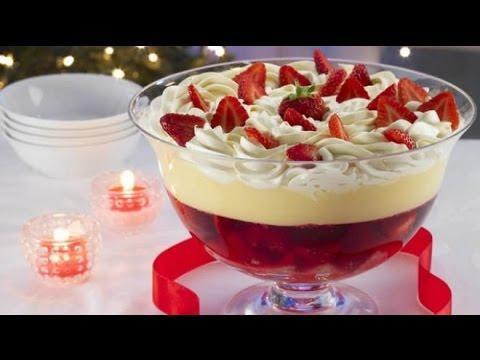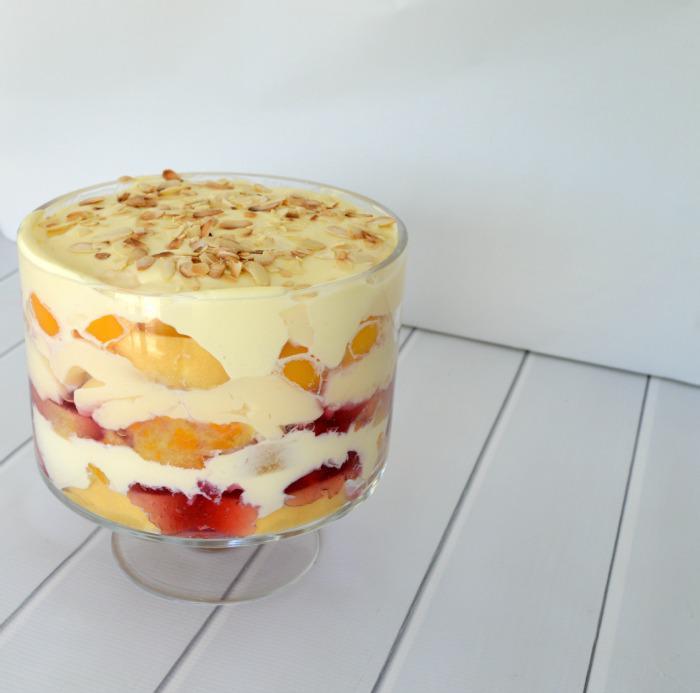The first image is the image on the left, the second image is the image on the right. Assess this claim about the two images: "An image shows spoons next to a trifle dessert.". Correct or not? Answer yes or no. No. 